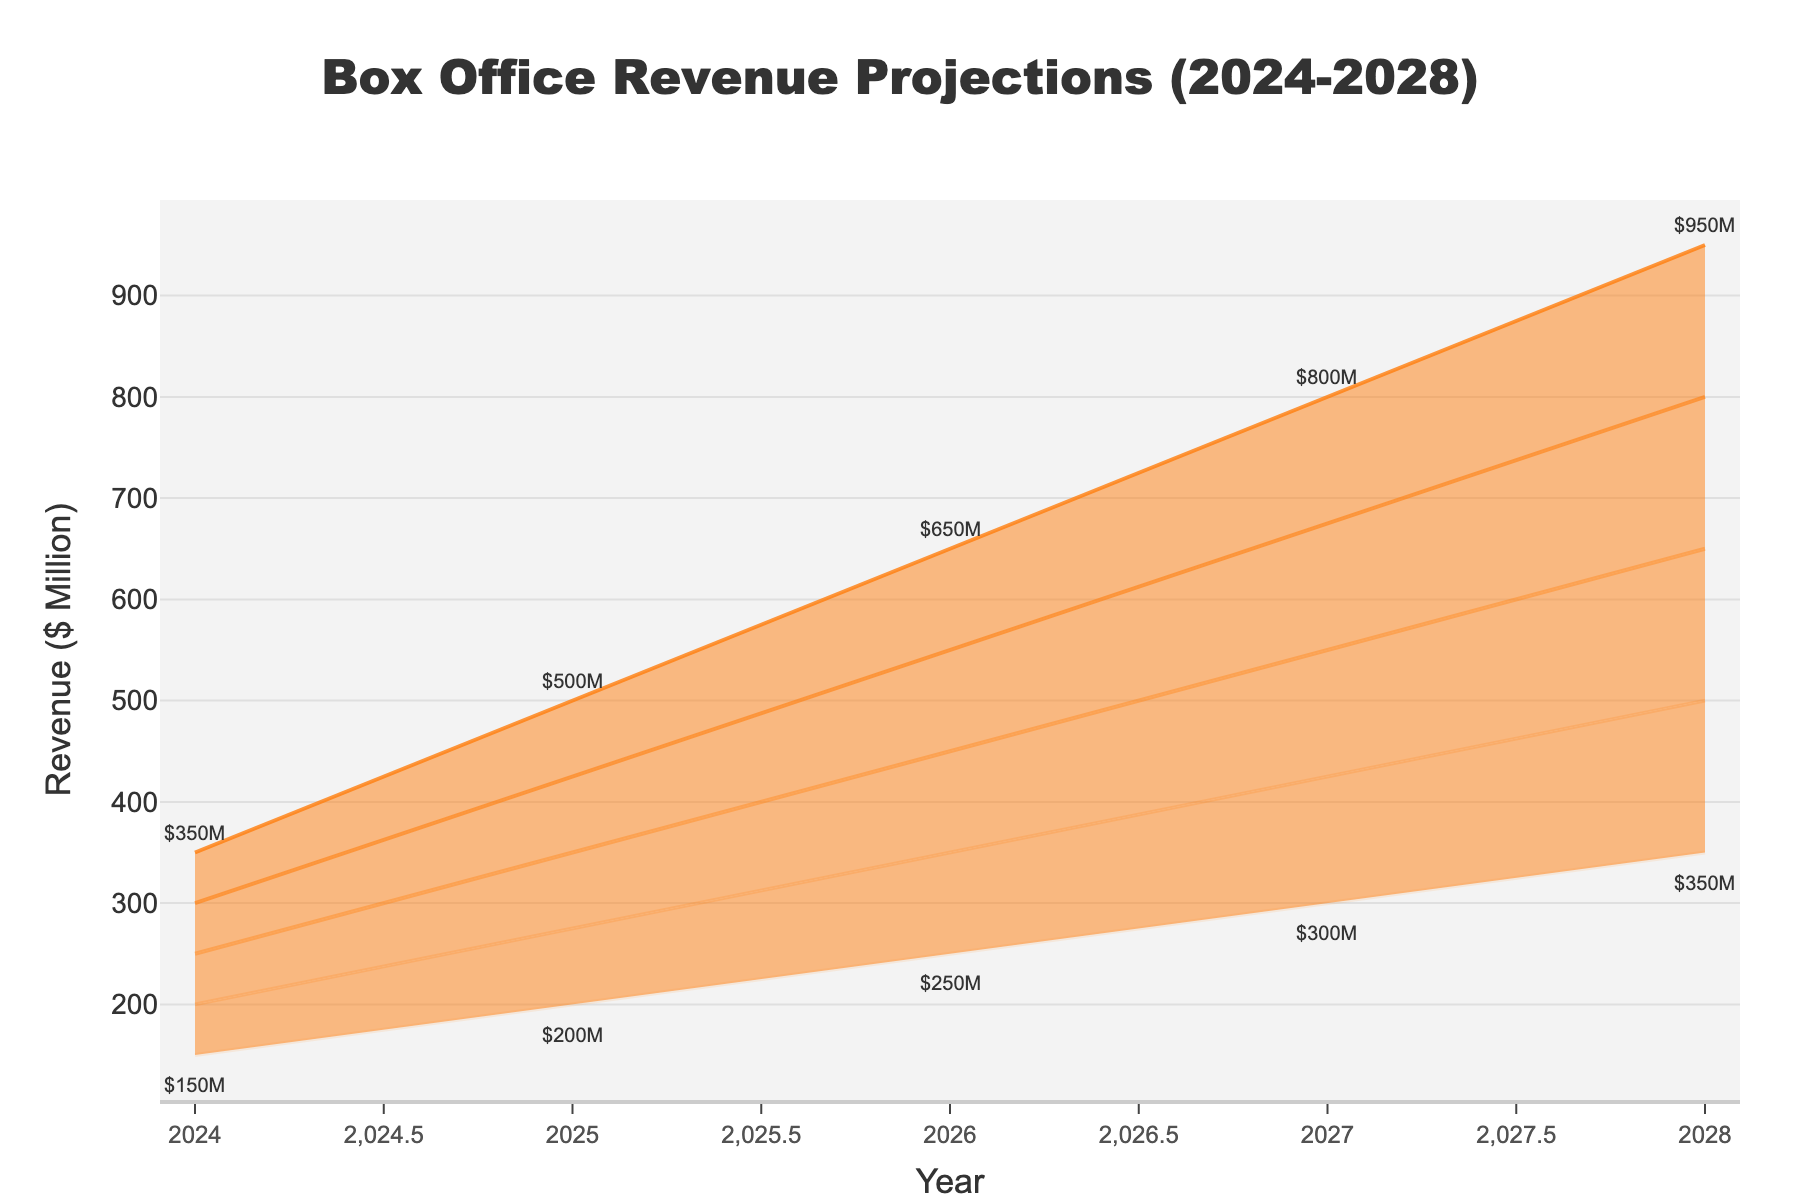What is the title of the figure? The title is located at the top of the figure and is designed to give an overall summary of what the visualization is about. From the data provided, the title is "Box Office Revenue Projections (2024-2028)".
Answer: Box Office Revenue Projections (2024-2028) Which year has the lowest high estimate? To find the year with the lowest high estimate, look at the "High Estimate" curve and identify the lowest value over the years. The lowest high estimate among 2024-2028 is $350M in 2024.
Answer: 2024 What is the mid estimate for the year 2027? The mid estimate can be identified by locating the middle line of the projections for the year 2027. The provided data shows that the mid estimate for 2027 is $550M.
Answer: $550M By how much is the high estimate in 2028 greater than the mid estimate in 2026? To find the difference, locate the values for the high estimate in 2028 and the mid estimate in 2026. The high estimate in 2028 is $950M, and the mid estimate in 2026 is $450M. Subtracting these values gives $950M - $450M = $500M.
Answer: $500M Which estimate range (Low-Mid, Mid-High, etc.) covers the widest span in 2025? To find the widest span, calculate the difference for each estimate range in 2025 (by subtracting lower value from higher value within the range). The differences are $275M - $200M = $75M, $350M - $275M = $75M, and so on. Each range is $75M, indicating that all ranges are equal.
Answer: All ranges are equal How do the estimates trend over the years from 2024 to 2028? This question looks at the overall pattern seen in the plot. All estimate ranges (Low to High) show increasing values over the years, indicating a projected upward trend in box office revenues from 2024 to 2028.
Answer: Increasing What is the difference between the high estimate and the low estimate in 2026? To find the difference, subtract the low estimate from the high estimate for the year 2026. From the data, high estimate is $650M, and low estimate is $250M. The difference is $650M - $250M = $400M.
Answer: $400M Which year shows the highest mid estimate projection? Check the "Mid Estimate" line to determine the highest value over the years from 2024 to 2028. The highest mid estimate is $650M in 2028.
Answer: 2028 What are the estimated revenue ranges for 2024? Identify the range of the estimates from low to high for the year 2024. The values are from $150M (Low Estimate) to $350M (High Estimate).
Answer: $150M to $350M 